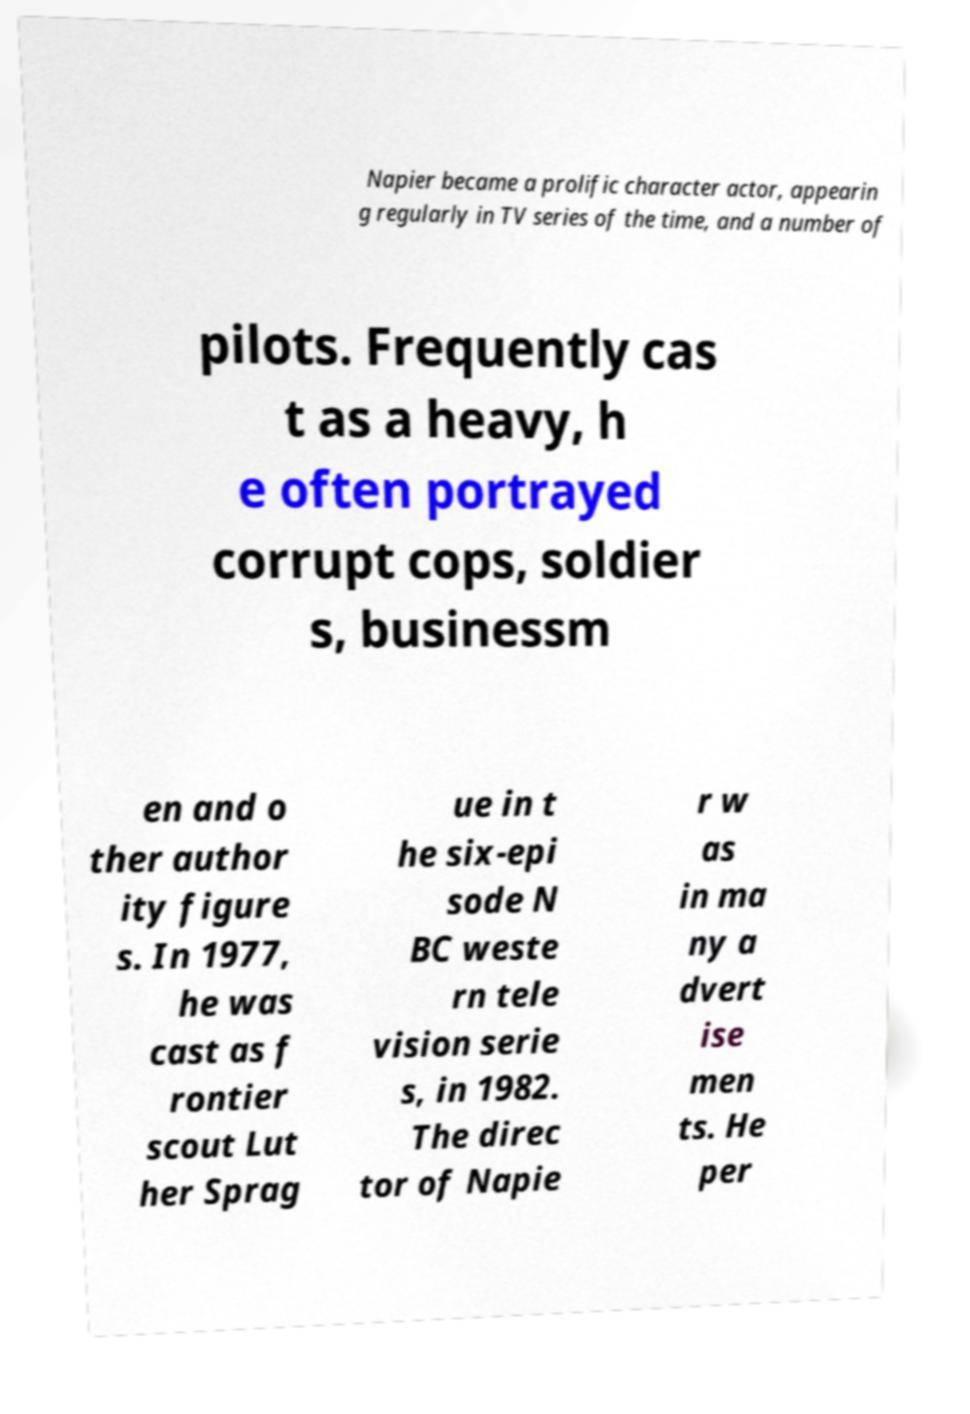I need the written content from this picture converted into text. Can you do that? Napier became a prolific character actor, appearin g regularly in TV series of the time, and a number of pilots. Frequently cas t as a heavy, h e often portrayed corrupt cops, soldier s, businessm en and o ther author ity figure s. In 1977, he was cast as f rontier scout Lut her Sprag ue in t he six-epi sode N BC weste rn tele vision serie s, in 1982. The direc tor of Napie r w as in ma ny a dvert ise men ts. He per 